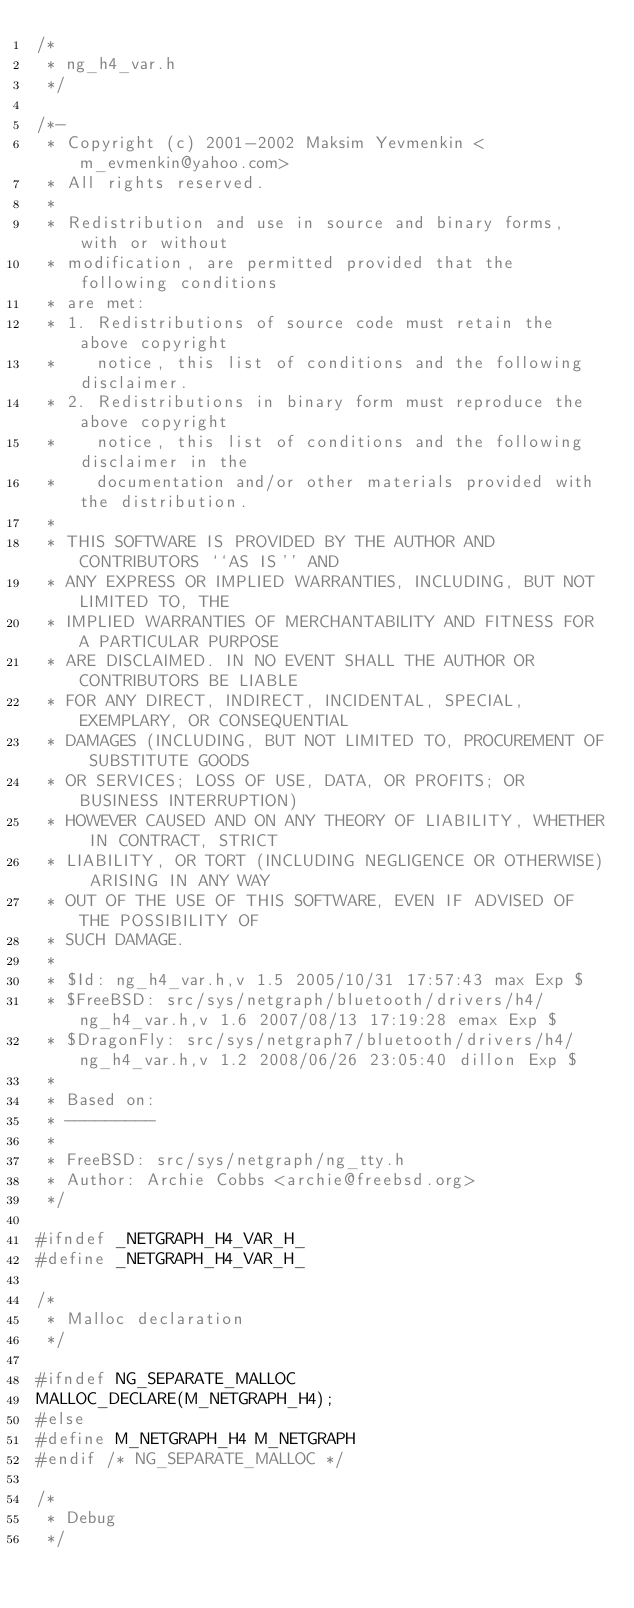<code> <loc_0><loc_0><loc_500><loc_500><_C_>/*
 * ng_h4_var.h
 */

/*-
 * Copyright (c) 2001-2002 Maksim Yevmenkin <m_evmenkin@yahoo.com>
 * All rights reserved.
 *
 * Redistribution and use in source and binary forms, with or without
 * modification, are permitted provided that the following conditions
 * are met:
 * 1. Redistributions of source code must retain the above copyright
 *    notice, this list of conditions and the following disclaimer.
 * 2. Redistributions in binary form must reproduce the above copyright
 *    notice, this list of conditions and the following disclaimer in the
 *    documentation and/or other materials provided with the distribution.
 *
 * THIS SOFTWARE IS PROVIDED BY THE AUTHOR AND CONTRIBUTORS ``AS IS'' AND
 * ANY EXPRESS OR IMPLIED WARRANTIES, INCLUDING, BUT NOT LIMITED TO, THE
 * IMPLIED WARRANTIES OF MERCHANTABILITY AND FITNESS FOR A PARTICULAR PURPOSE
 * ARE DISCLAIMED. IN NO EVENT SHALL THE AUTHOR OR CONTRIBUTORS BE LIABLE
 * FOR ANY DIRECT, INDIRECT, INCIDENTAL, SPECIAL, EXEMPLARY, OR CONSEQUENTIAL
 * DAMAGES (INCLUDING, BUT NOT LIMITED TO, PROCUREMENT OF SUBSTITUTE GOODS
 * OR SERVICES; LOSS OF USE, DATA, OR PROFITS; OR BUSINESS INTERRUPTION)
 * HOWEVER CAUSED AND ON ANY THEORY OF LIABILITY, WHETHER IN CONTRACT, STRICT
 * LIABILITY, OR TORT (INCLUDING NEGLIGENCE OR OTHERWISE) ARISING IN ANY WAY
 * OUT OF THE USE OF THIS SOFTWARE, EVEN IF ADVISED OF THE POSSIBILITY OF
 * SUCH DAMAGE.
 *
 * $Id: ng_h4_var.h,v 1.5 2005/10/31 17:57:43 max Exp $
 * $FreeBSD: src/sys/netgraph/bluetooth/drivers/h4/ng_h4_var.h,v 1.6 2007/08/13 17:19:28 emax Exp $
 * $DragonFly: src/sys/netgraph7/bluetooth/drivers/h4/ng_h4_var.h,v 1.2 2008/06/26 23:05:40 dillon Exp $
 * 
 * Based on:
 * ---------
 *
 * FreeBSD: src/sys/netgraph/ng_tty.h
 * Author: Archie Cobbs <archie@freebsd.org>
 */

#ifndef _NETGRAPH_H4_VAR_H_
#define _NETGRAPH_H4_VAR_H_

/*
 * Malloc declaration
 */

#ifndef NG_SEPARATE_MALLOC
MALLOC_DECLARE(M_NETGRAPH_H4);
#else
#define M_NETGRAPH_H4 M_NETGRAPH
#endif /* NG_SEPARATE_MALLOC */

/* 
 * Debug
 */
</code> 